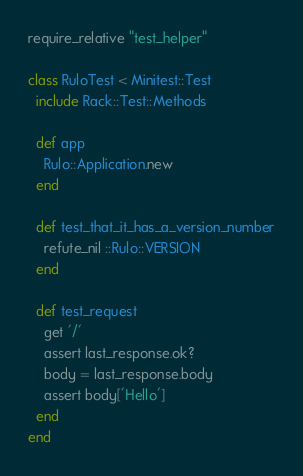<code> <loc_0><loc_0><loc_500><loc_500><_Ruby_>require_relative "test_helper"

class RuloTest < Minitest::Test
  include Rack::Test::Methods

  def app
    Rulo::Application.new
  end

  def test_that_it_has_a_version_number
    refute_nil ::Rulo::VERSION
  end

  def test_request
    get '/'
    assert last_response.ok?
    body = last_response.body
    assert body['Hello']
  end
end
</code> 